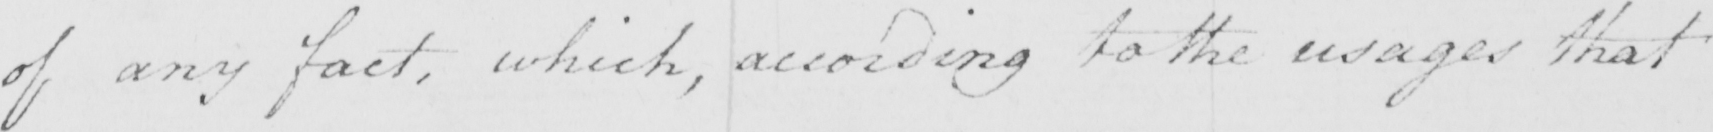Can you tell me what this handwritten text says? of any fact , which , according to the usages that 